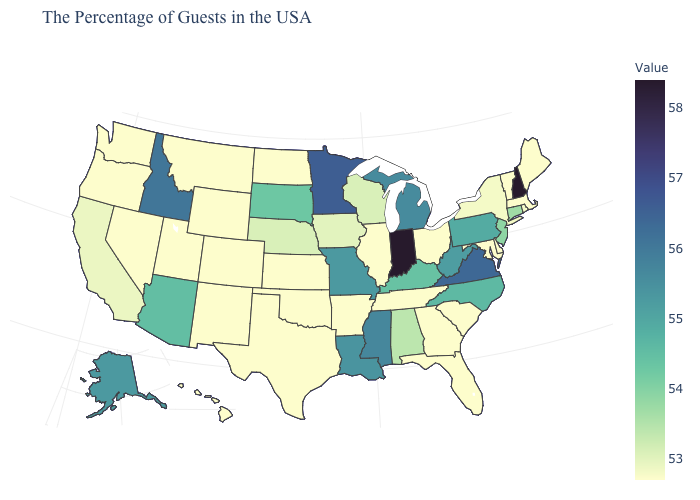Does Illinois have the lowest value in the MidWest?
Answer briefly. Yes. Does the map have missing data?
Answer briefly. No. Among the states that border Nevada , does Utah have the lowest value?
Short answer required. Yes. Does the map have missing data?
Concise answer only. No. Does the map have missing data?
Short answer required. No. Which states have the highest value in the USA?
Keep it brief. New Hampshire, Indiana. Does Massachusetts have the lowest value in the Northeast?
Answer briefly. Yes. Does Virginia have a higher value than New Hampshire?
Write a very short answer. No. 